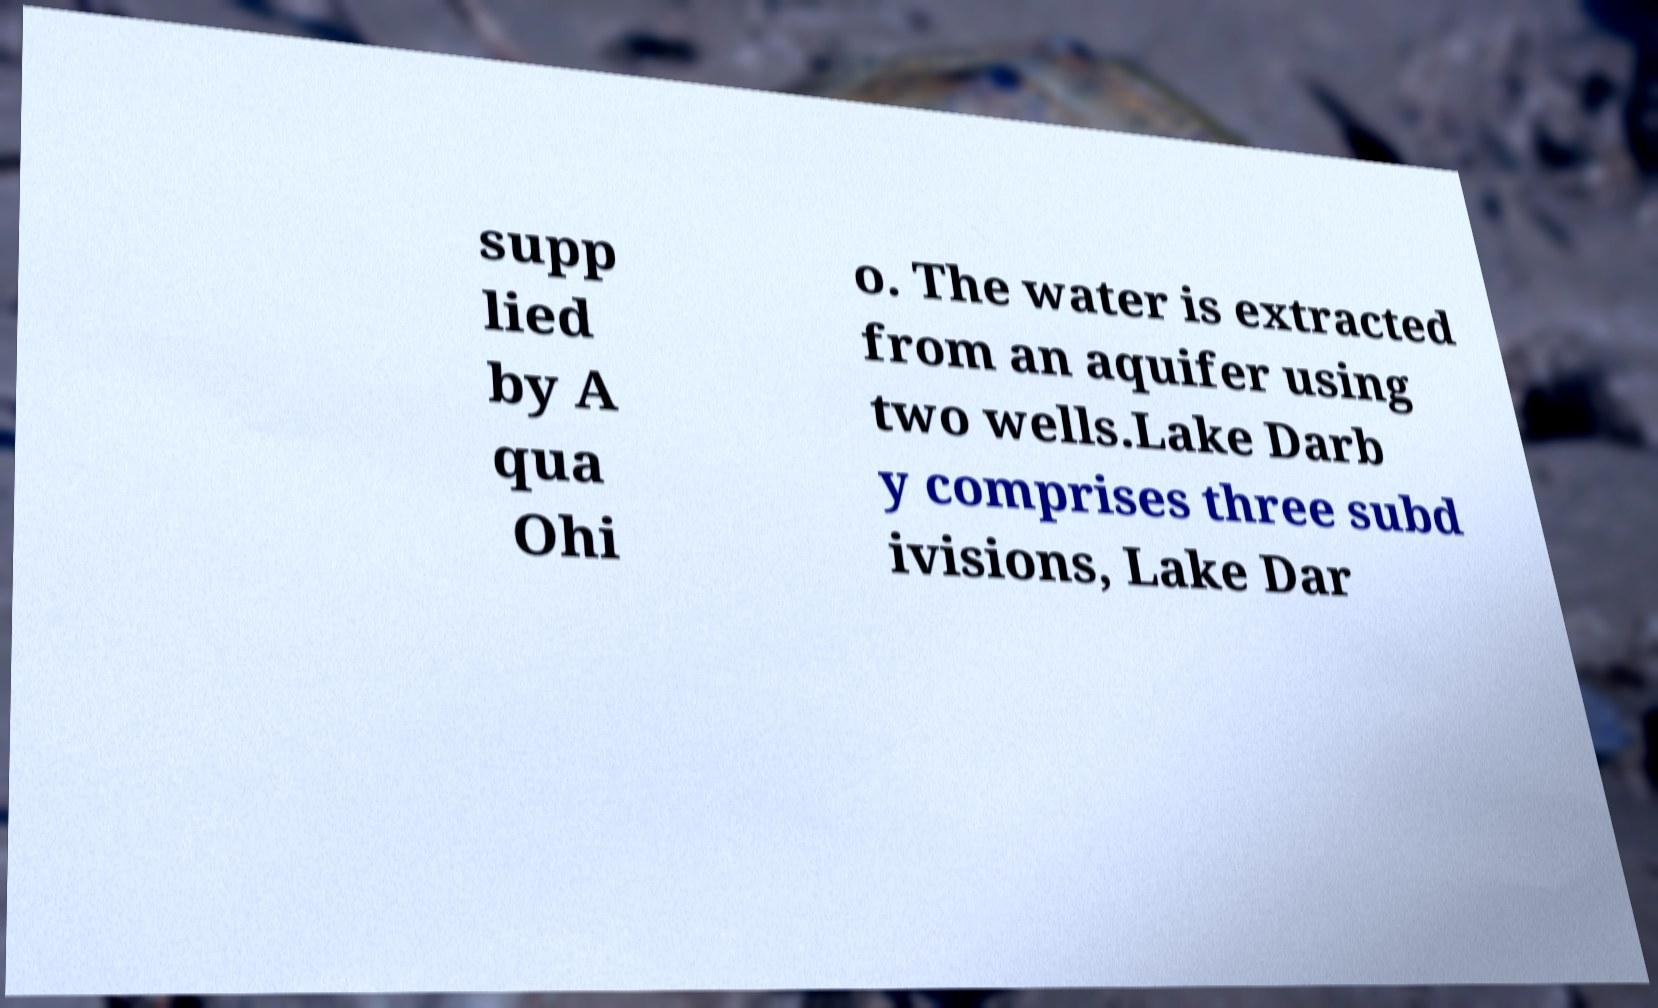There's text embedded in this image that I need extracted. Can you transcribe it verbatim? supp lied by A qua Ohi o. The water is extracted from an aquifer using two wells.Lake Darb y comprises three subd ivisions, Lake Dar 